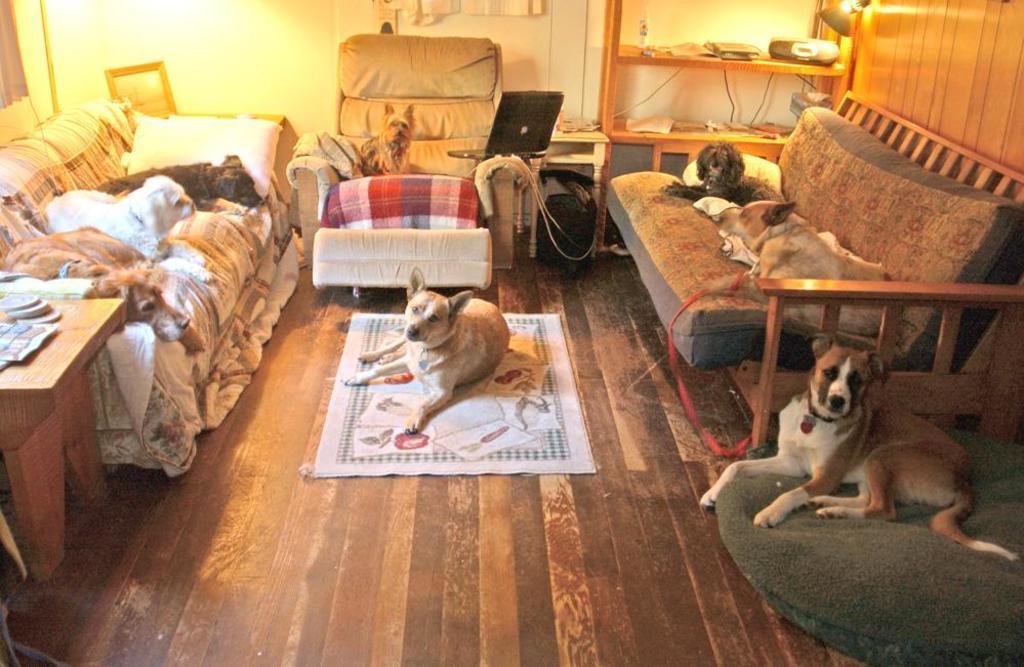Please provide a concise description of this image. There are dogs on the sofas. This is floor and there is a mat. Here we can see two dogs sitting on the floor. This is table. There is a laptop and this is rack. In the background there is a wall. 